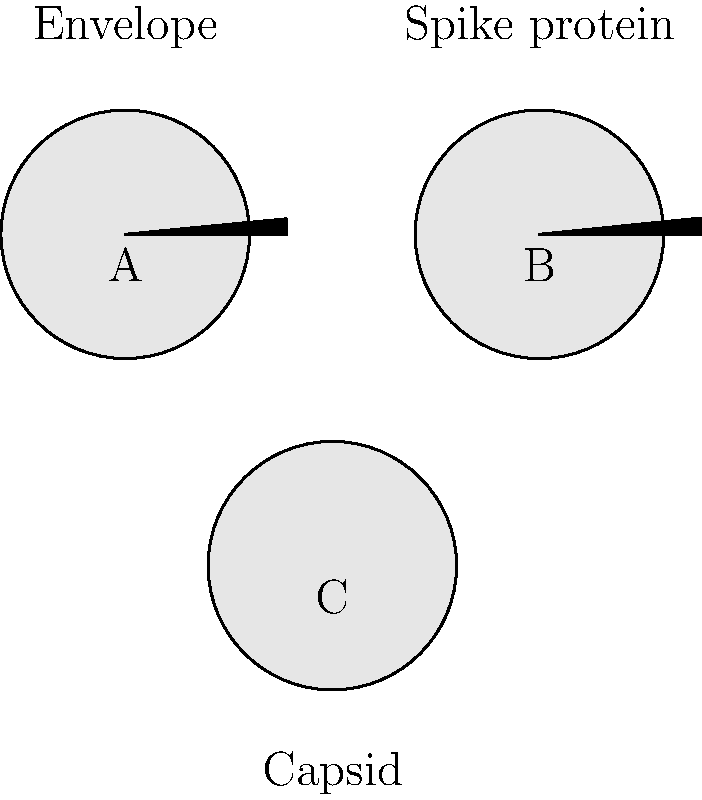Based on the simplified diagrams of virus structures shown above, which virus type is most likely to represent a non-enveloped virus, and how does this structure relate to its stability in the environment? To answer this question, let's analyze the structures step-by-step:

1. Virus A: Has a circular structure with 8 spike proteins protruding from its surface. This represents an enveloped virus with a lipid bilayer and embedded spike proteins.

2. Virus B: Similar to A, but with 12 spike proteins. This also represents an enveloped virus.

3. Virus C: Has a circular structure without any spike proteins. This represents a non-enveloped virus, consisting only of a protein capsid.

4. Non-enveloped viruses, like the one represented by C, are generally more stable in the environment due to their structure:

   a) They lack a lipid envelope, which is sensitive to environmental factors like heat, desiccation, and detergents.
   
   b) The protein capsid provides better protection for the viral genetic material.
   
   c) This increased stability allows non-enveloped viruses to survive longer outside a host, potentially increasing their transmission rates.

5. Examples of non-enveloped viruses include:
   - Poliovirus
   - Norovirus
   - Rotavirus

6. In contrast, enveloped viruses (like A and B) are generally less stable in the environment due to their lipid envelope, which can be easily disrupted by environmental factors.

Therefore, virus C represents a non-enveloped virus, which is typically more stable in the environment due to its protective protein capsid and lack of a fragile lipid envelope.
Answer: Virus C; non-enveloped structure provides greater environmental stability 